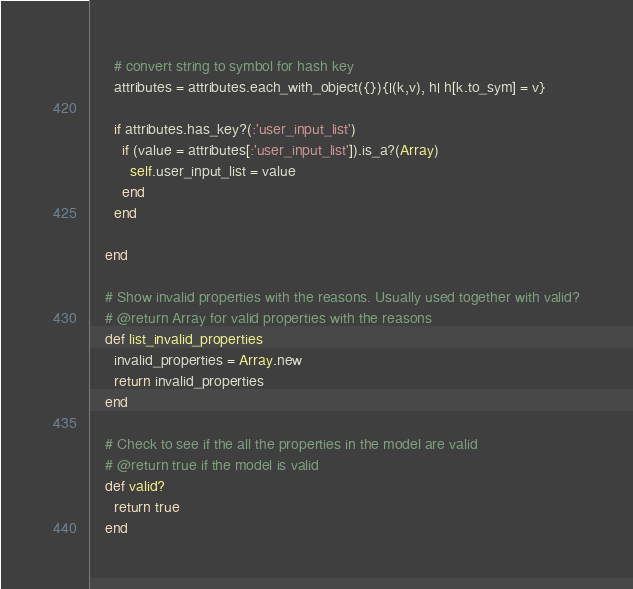<code> <loc_0><loc_0><loc_500><loc_500><_Ruby_>
      # convert string to symbol for hash key
      attributes = attributes.each_with_object({}){|(k,v), h| h[k.to_sym] = v}

      if attributes.has_key?(:'user_input_list')
        if (value = attributes[:'user_input_list']).is_a?(Array)
          self.user_input_list = value
        end
      end

    end

    # Show invalid properties with the reasons. Usually used together with valid?
    # @return Array for valid properties with the reasons
    def list_invalid_properties
      invalid_properties = Array.new
      return invalid_properties
    end

    # Check to see if the all the properties in the model are valid
    # @return true if the model is valid
    def valid?
      return true
    end
</code> 